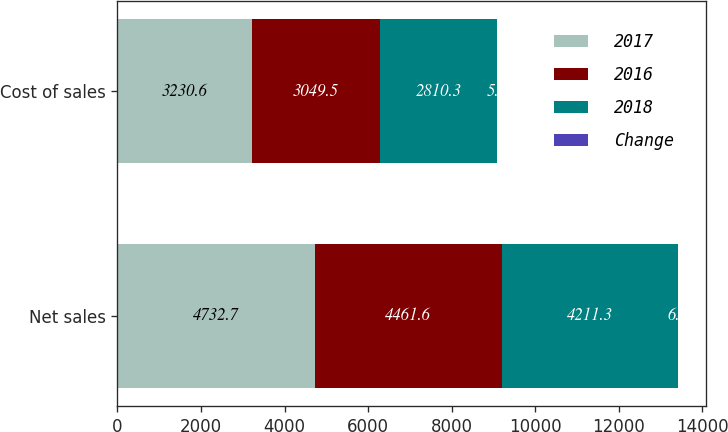Convert chart to OTSL. <chart><loc_0><loc_0><loc_500><loc_500><stacked_bar_chart><ecel><fcel>Net sales<fcel>Cost of sales<nl><fcel>2017<fcel>4732.7<fcel>3230.6<nl><fcel>2016<fcel>4461.6<fcel>3049.5<nl><fcel>2018<fcel>4211.3<fcel>2810.3<nl><fcel>Change<fcel>6.1<fcel>5.9<nl></chart> 